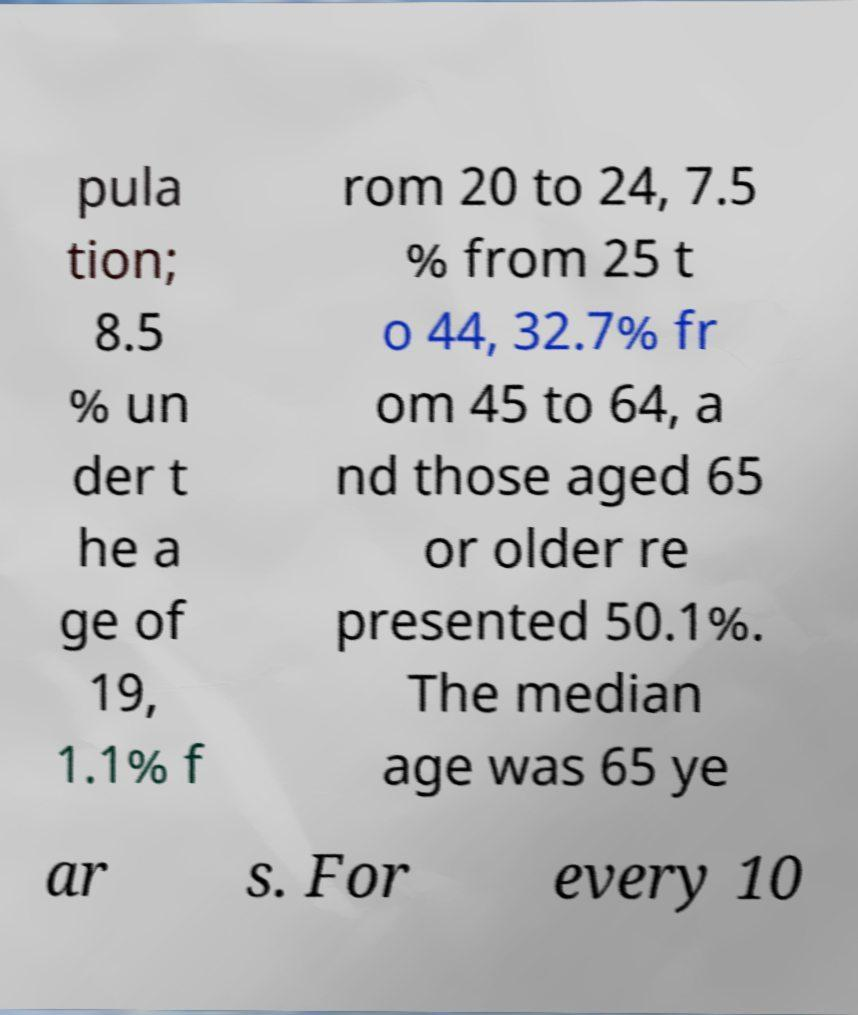Please read and relay the text visible in this image. What does it say? pula tion; 8.5 % un der t he a ge of 19, 1.1% f rom 20 to 24, 7.5 % from 25 t o 44, 32.7% fr om 45 to 64, a nd those aged 65 or older re presented 50.1%. The median age was 65 ye ar s. For every 10 